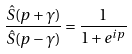<formula> <loc_0><loc_0><loc_500><loc_500>\frac { \hat { S } ( p + \gamma ) } { \hat { S } ( p - \gamma ) } = \frac { 1 } { 1 + e ^ { i p } }</formula> 